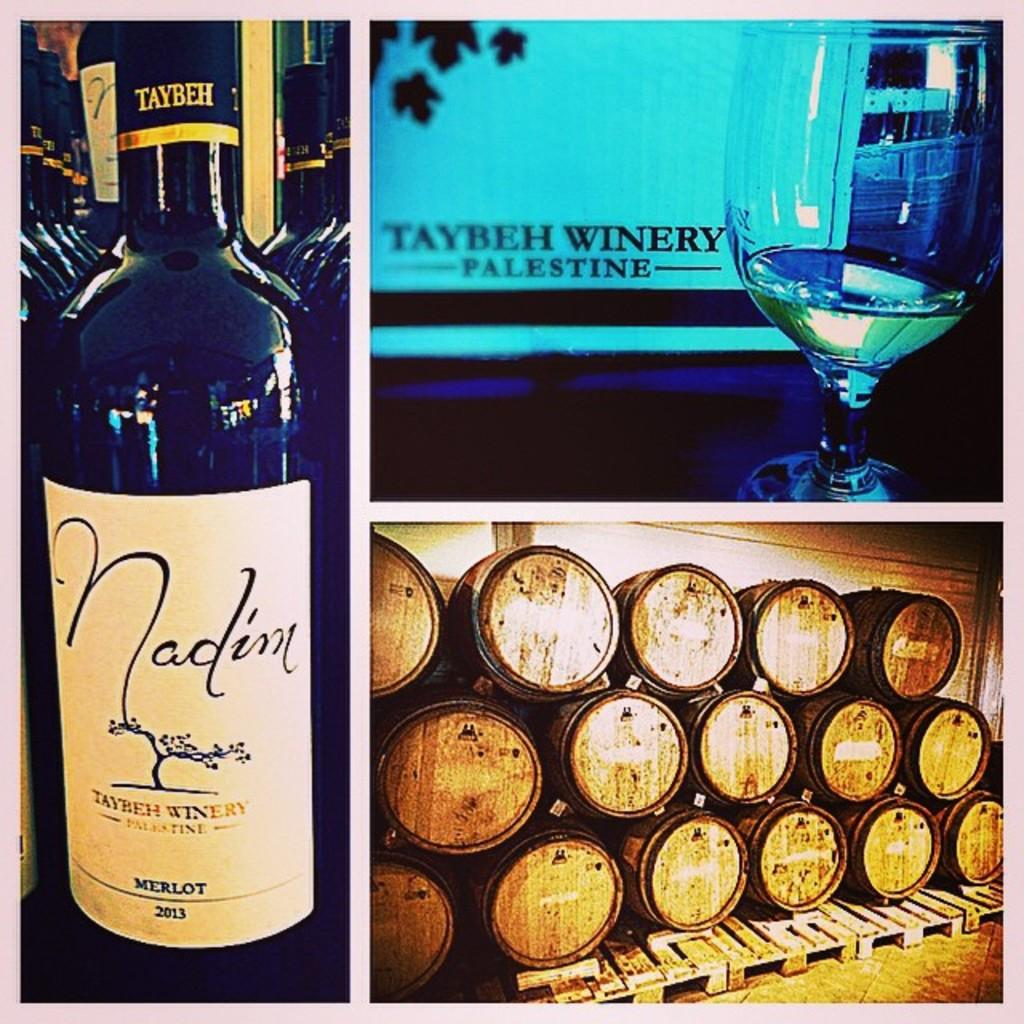<image>
Create a compact narrative representing the image presented. A bottle of merlot is shown with a glass of wine and a pile of barrels. 